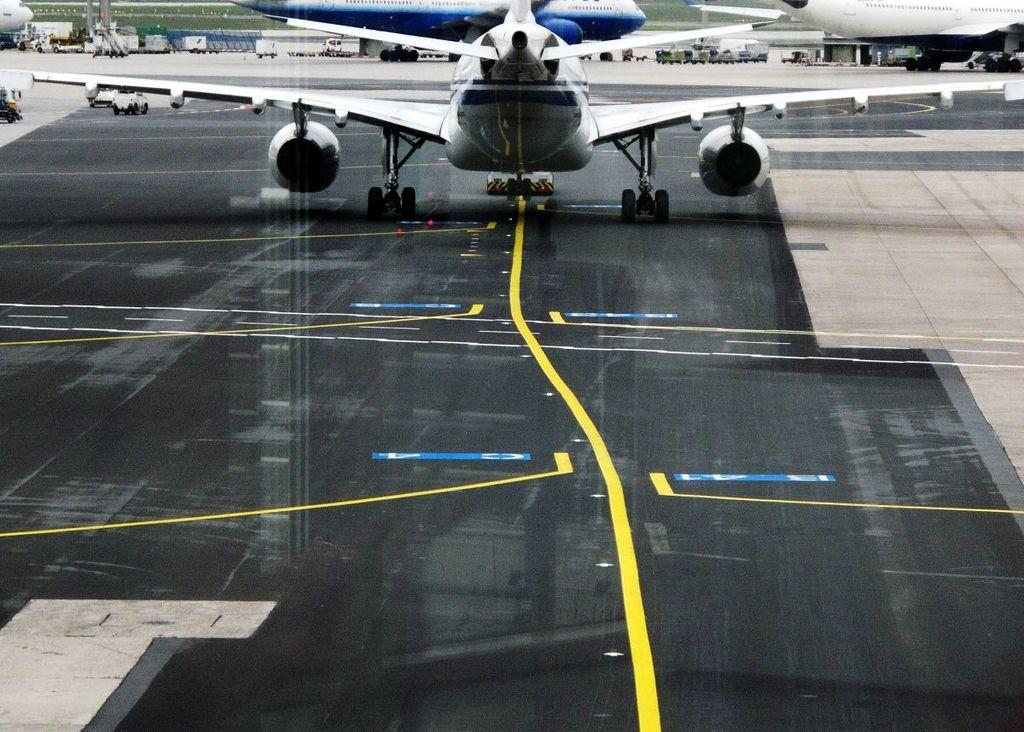What can be seen on the runway in the image? There are aeroplanes on the runway in the image. What else is visible on the left side of the image? There are vehicles on the left side of the image. What type of pan is being used in the protest in the image? There is no protest or pan present in the image; it features aeroplanes on the runway and vehicles on the left side. 